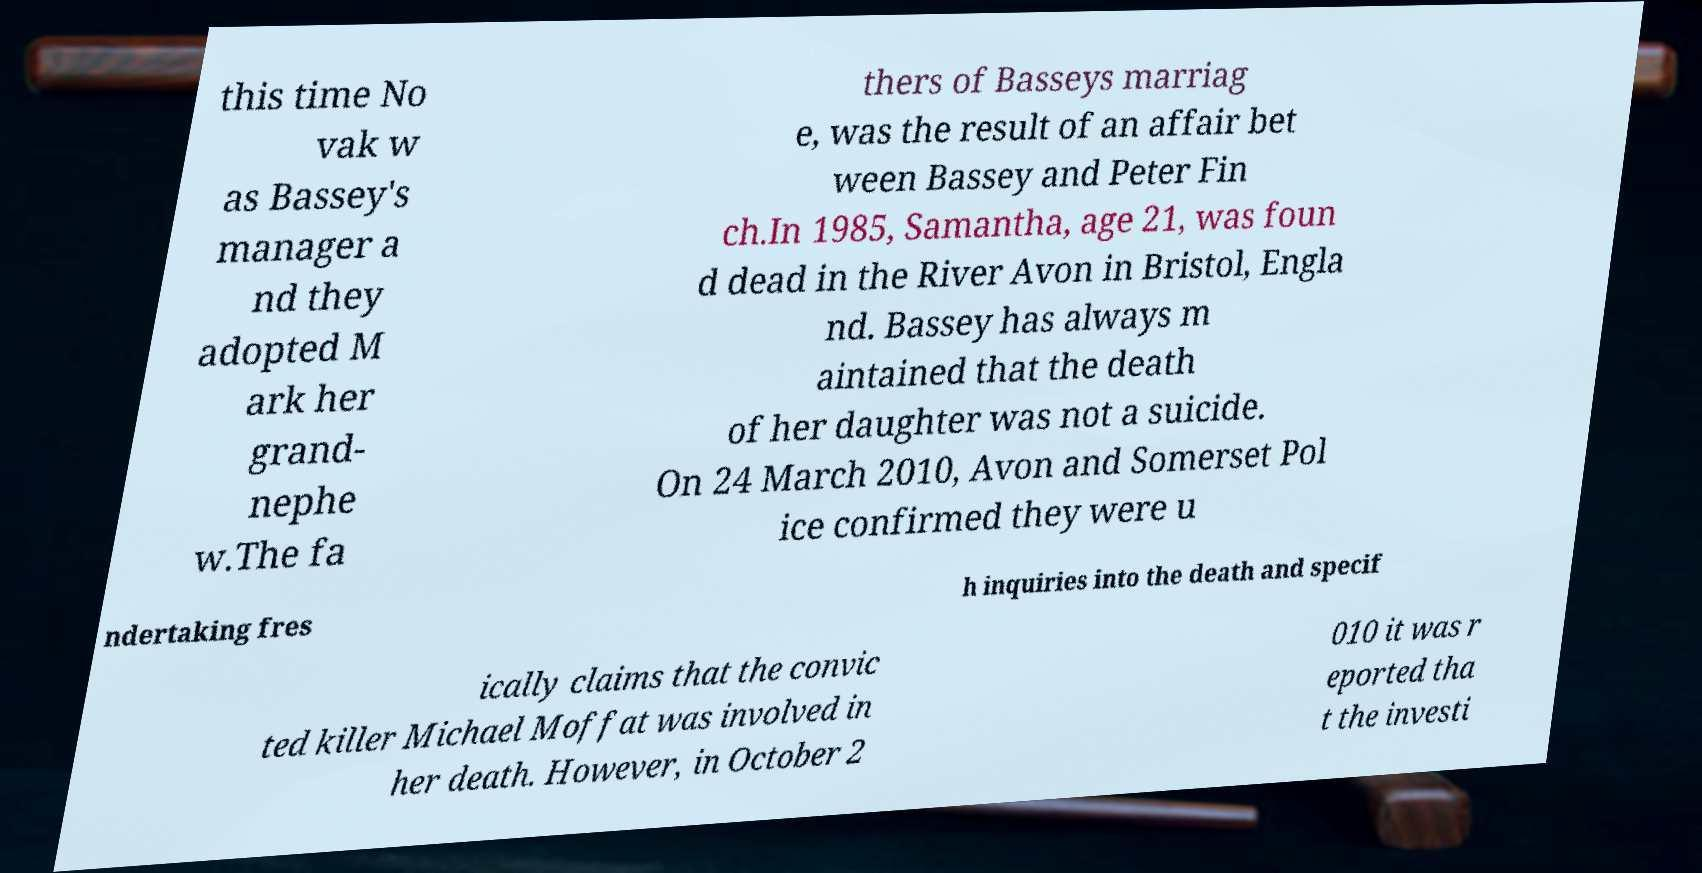Please identify and transcribe the text found in this image. this time No vak w as Bassey's manager a nd they adopted M ark her grand- nephe w.The fa thers of Basseys marriag e, was the result of an affair bet ween Bassey and Peter Fin ch.In 1985, Samantha, age 21, was foun d dead in the River Avon in Bristol, Engla nd. Bassey has always m aintained that the death of her daughter was not a suicide. On 24 March 2010, Avon and Somerset Pol ice confirmed they were u ndertaking fres h inquiries into the death and specif ically claims that the convic ted killer Michael Moffat was involved in her death. However, in October 2 010 it was r eported tha t the investi 